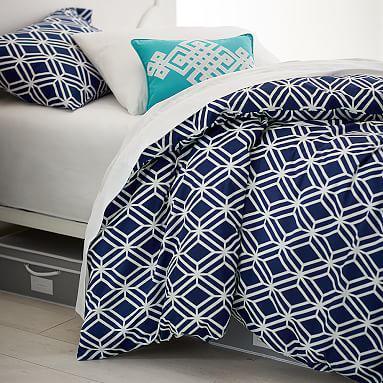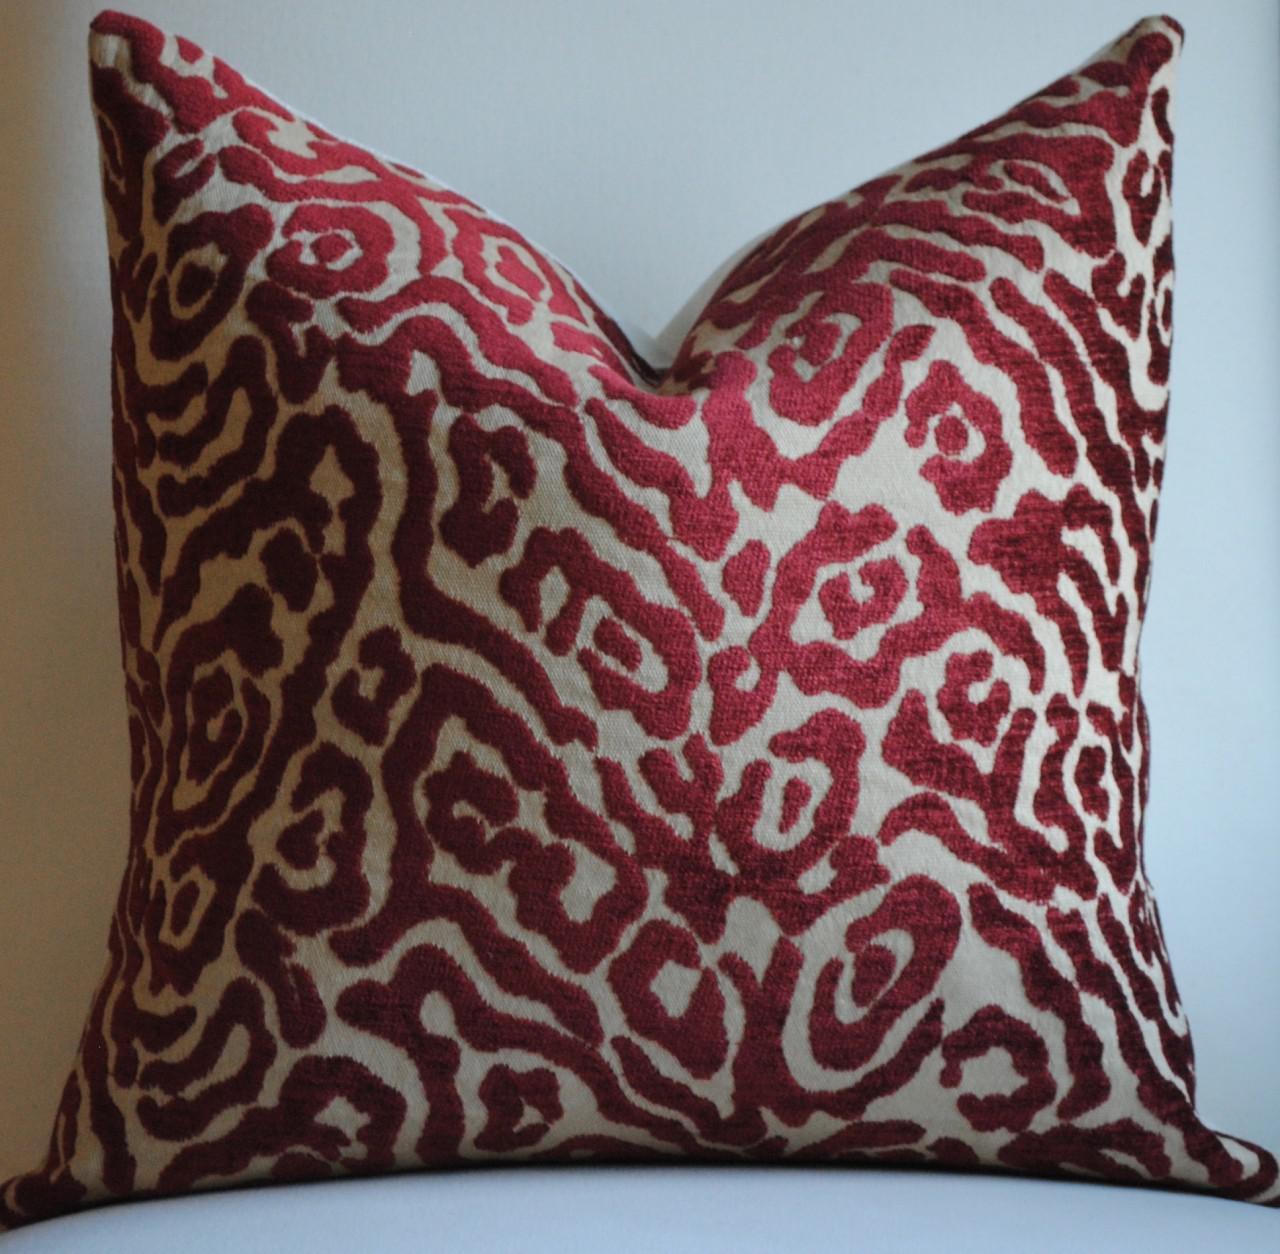The first image is the image on the left, the second image is the image on the right. Considering the images on both sides, is "There is a child on top of the pillow in at least one of the images." valid? Answer yes or no. No. 